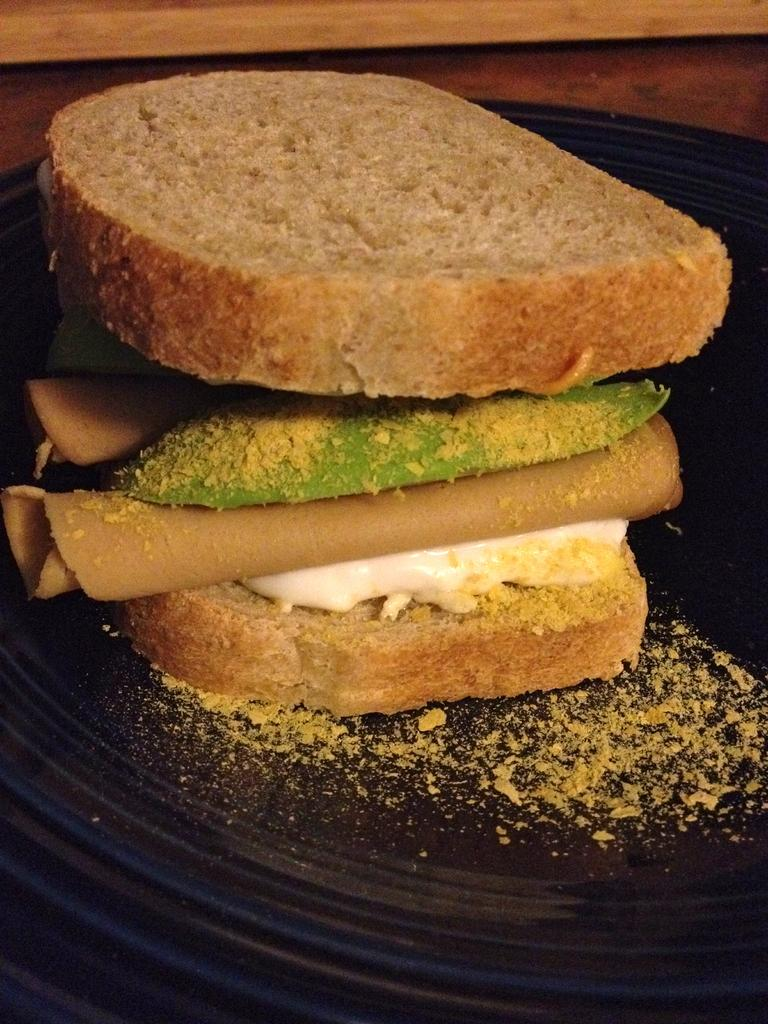What is on the plate in the image? There are food items on a plate in the image. What can be seen in the background of the image? There is wood visible in the background of the image. How does the food on the plate burst into flames in the image? The food on the plate does not burst into flames in the image; there is no indication of fire or heat. 